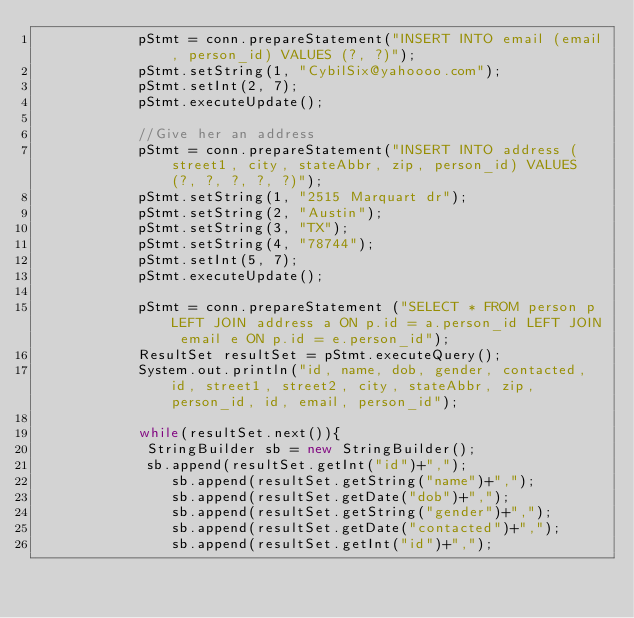<code> <loc_0><loc_0><loc_500><loc_500><_Java_>            pStmt = conn.prepareStatement("INSERT INTO email (email, person_id) VALUES (?, ?)");
            pStmt.setString(1, "CybilSix@yahoooo.com");
            pStmt.setInt(2, 7);
            pStmt.executeUpdate();

            //Give her an address
            pStmt = conn.prepareStatement("INSERT INTO address (street1, city, stateAbbr, zip, person_id) VALUES (?, ?, ?, ?, ?)");
            pStmt.setString(1, "2515 Marquart dr");
            pStmt.setString(2, "Austin");
            pStmt.setString(3, "TX");
            pStmt.setString(4, "78744");
            pStmt.setInt(5, 7);
            pStmt.executeUpdate();

            pStmt = conn.prepareStatement ("SELECT * FROM person p LEFT JOIN address a ON p.id = a.person_id LEFT JOIN email e ON p.id = e.person_id");
            ResultSet resultSet = pStmt.executeQuery();
            System.out.println("id, name, dob, gender, contacted, id, street1, street2, city, stateAbbr, zip, person_id, id, email, person_id");
            
            while(resultSet.next()){
             StringBuilder sb = new StringBuilder();
             sb.append(resultSet.getInt("id")+",");
                sb.append(resultSet.getString("name")+",");
                sb.append(resultSet.getDate("dob")+",");
                sb.append(resultSet.getString("gender")+",");
                sb.append(resultSet.getDate("contacted")+",");
                sb.append(resultSet.getInt("id")+",");</code> 